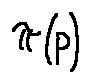Convert formula to latex. <formula><loc_0><loc_0><loc_500><loc_500>\pi ( p )</formula> 